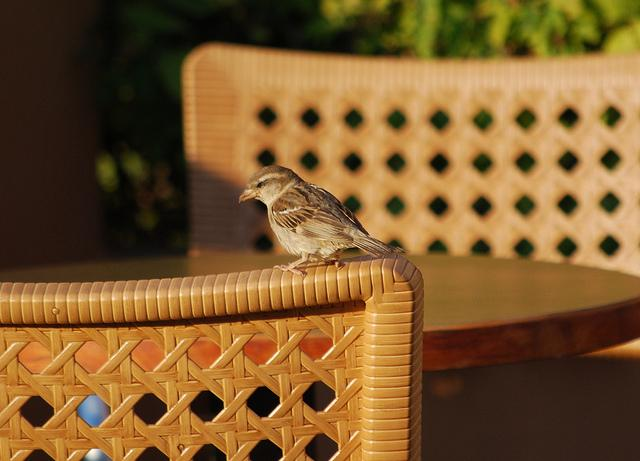What materials are the chairs made of?

Choices:
A) metal
B) bamboo
C) ceramic
D) wood bamboo 